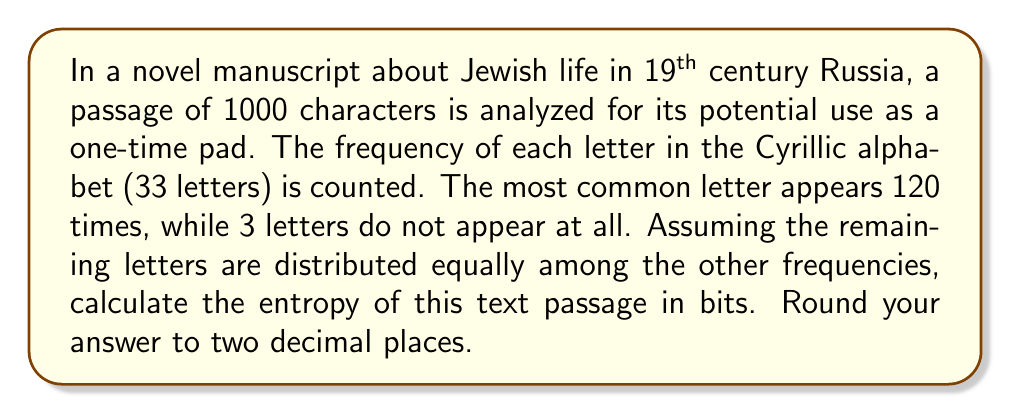What is the answer to this math problem? To calculate the entropy of the text, we'll use Shannon's entropy formula:

$$ H = -\sum_{i=1}^{n} p_i \log_2(p_i) $$

Where $p_i$ is the probability of each symbol (letter) occurring.

Step 1: Calculate the probabilities
- Most common letter: $p_1 = \frac{120}{1000} = 0.12$
- 3 letters don't appear: $p_{31} = p_{32} = p_{33} = 0$
- Remaining 29 letters: $\frac{1000 - 120}{29} = 30.3448$ times each
  $p_2 = p_3 = ... = p_{30} = \frac{30.3448}{1000} = 0.0303448$

Step 2: Calculate each term of the summation
- For $p_1$: $-0.12 \log_2(0.12) = 0.3672$
- For each $p_i$ from 2 to 30:
  $-0.0303448 \log_2(0.0303448) = 0.1527$
- For $p_{31}, p_{32}, p_{33}$: $0$ (as $\lim_{x \to 0} x \log_2(x) = 0$)

Step 3: Sum all terms
$H = 0.3672 + 29 * 0.1527 = 4.7955$ bits

Step 4: Round to two decimal places
$H \approx 4.80$ bits
Answer: 4.80 bits 